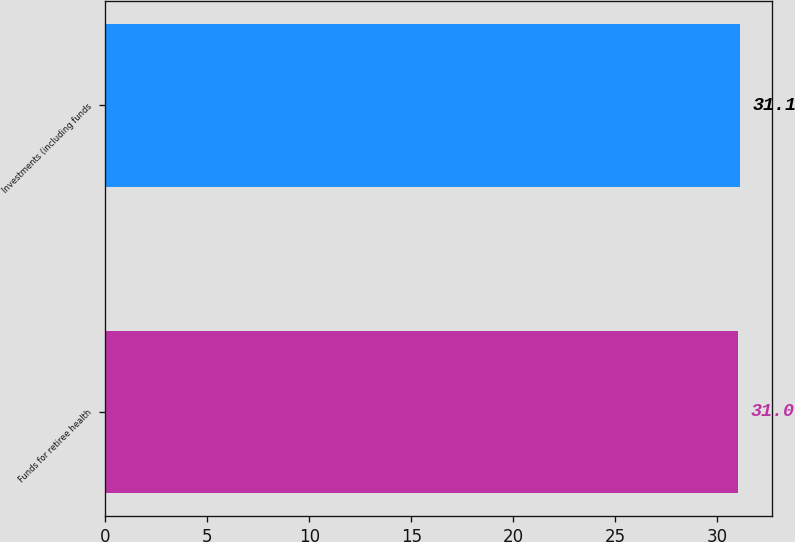<chart> <loc_0><loc_0><loc_500><loc_500><bar_chart><fcel>Funds for retiree health<fcel>Investments (including funds<nl><fcel>31<fcel>31.1<nl></chart> 